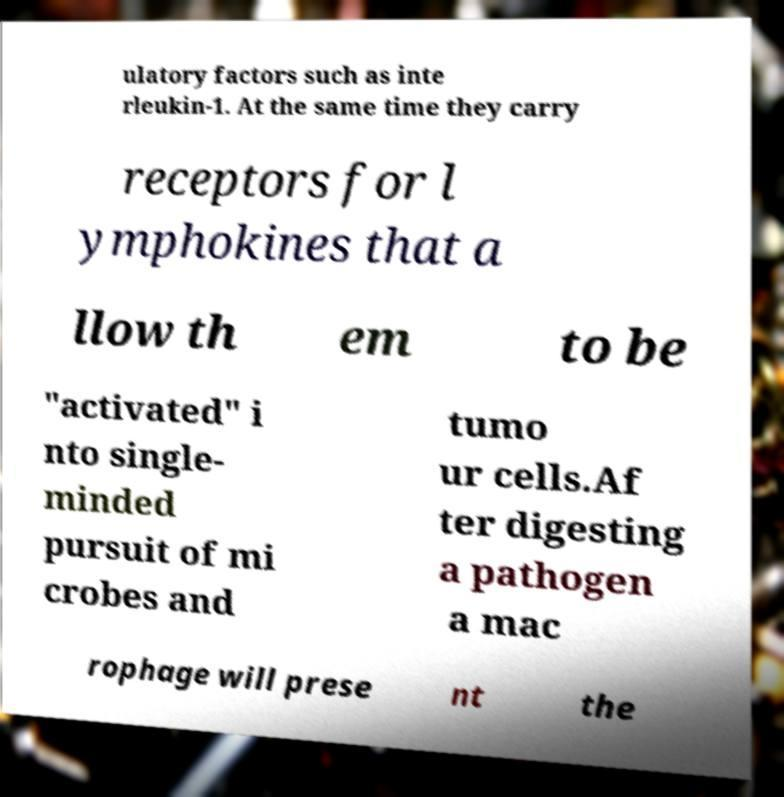Could you extract and type out the text from this image? ulatory factors such as inte rleukin-1. At the same time they carry receptors for l ymphokines that a llow th em to be "activated" i nto single- minded pursuit of mi crobes and tumo ur cells.Af ter digesting a pathogen a mac rophage will prese nt the 